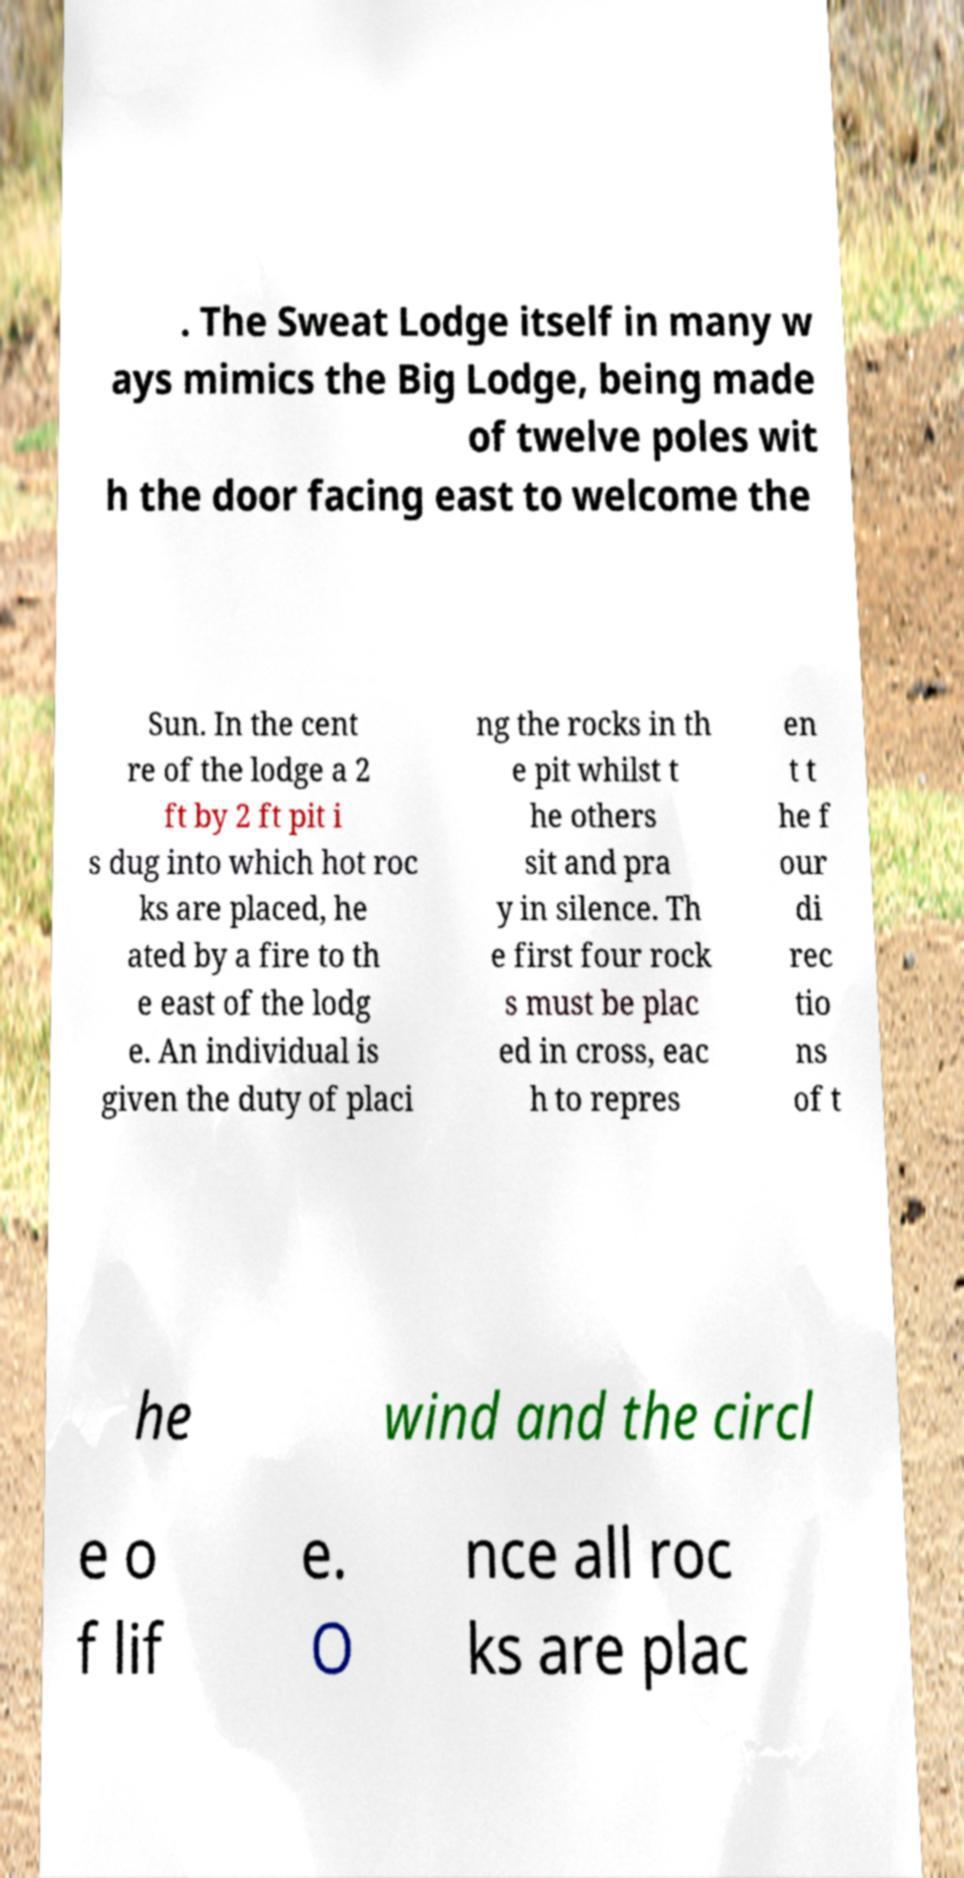I need the written content from this picture converted into text. Can you do that? . The Sweat Lodge itself in many w ays mimics the Big Lodge, being made of twelve poles wit h the door facing east to welcome the Sun. In the cent re of the lodge a 2 ft by 2 ft pit i s dug into which hot roc ks are placed, he ated by a fire to th e east of the lodg e. An individual is given the duty of placi ng the rocks in th e pit whilst t he others sit and pra y in silence. Th e first four rock s must be plac ed in cross, eac h to repres en t t he f our di rec tio ns of t he wind and the circl e o f lif e. O nce all roc ks are plac 